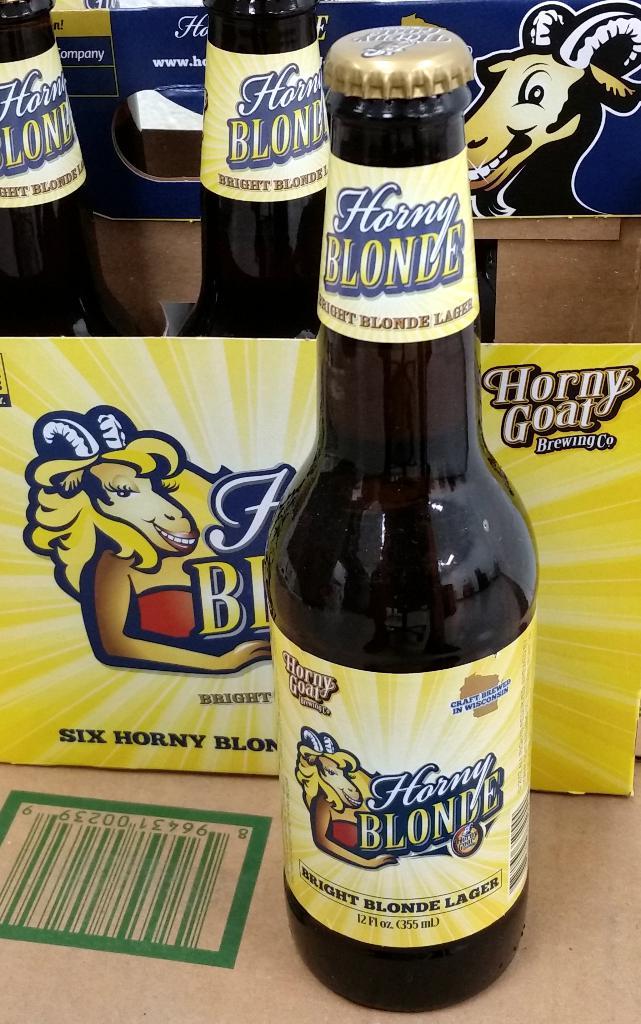Is horny goat a lager?
Your response must be concise. Yes. 